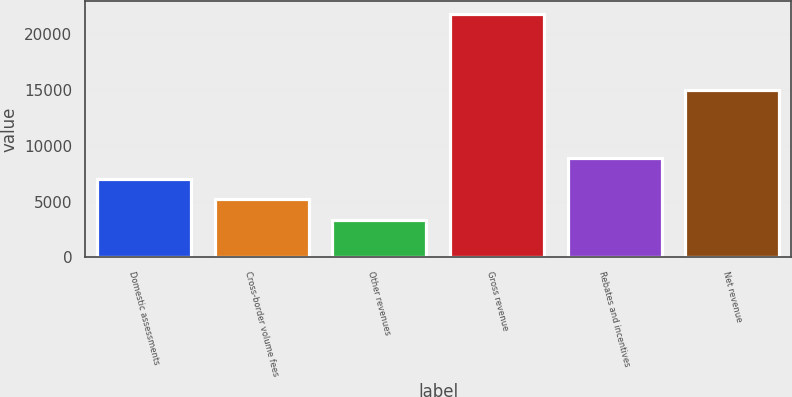<chart> <loc_0><loc_0><loc_500><loc_500><bar_chart><fcel>Domestic assessments<fcel>Cross-border volume fees<fcel>Other revenues<fcel>Gross revenue<fcel>Rebates and incentives<fcel>Net revenue<nl><fcel>7044.6<fcel>5196.3<fcel>3348<fcel>21831<fcel>8892.9<fcel>14950<nl></chart> 